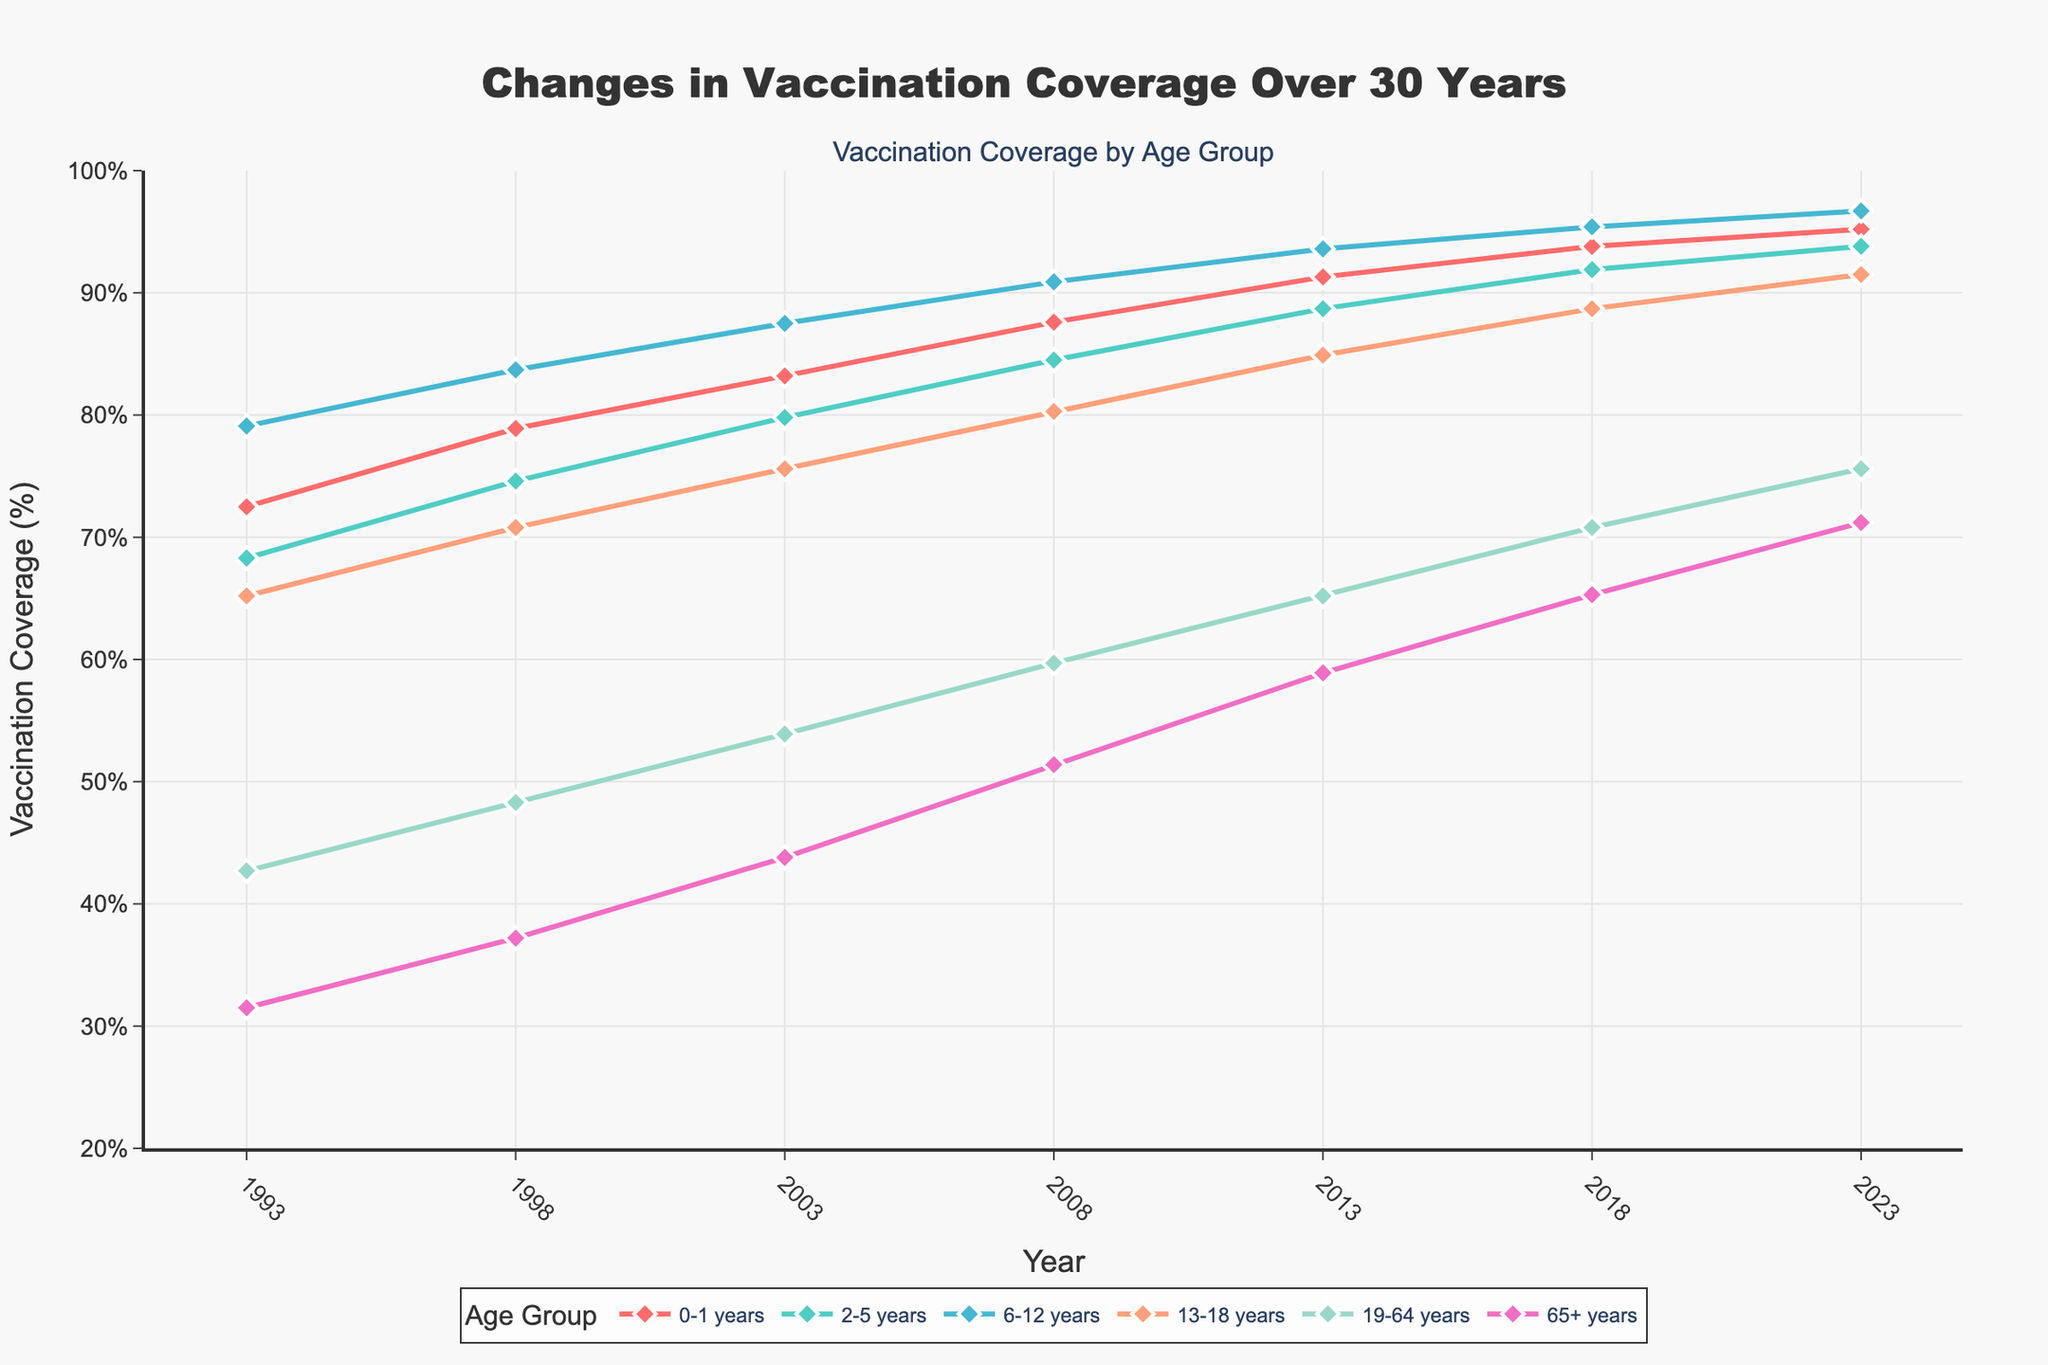What's the trend in vaccination coverage for the 0-1 years age group over the 30-year period? To understand the trend, observe the line representing the 0-1 years age group from 1993 to 2023. The line shows a continuous increase from 72.5% in 1993 to 95.2% in 2023, indicating a positive trend in vaccination coverage.
Answer: Increasing Which age group had the highest vaccination coverage in 2023? Review the endpoints of each line in 2023. The 6-12 years age group has the highest vaccination coverage at 96.7%.
Answer: 6-12 years By how many percentage points did the vaccination coverage for the 19-64 years age group increase from 1993 to 2023? Look at the values for the 19-64 years age group in 1993 and 2023. The coverage increased from 42.7% in 1993 to 75.6% in 2023. The difference is 75.6% - 42.7% = 32.9 percentage points.
Answer: 32.9 percentage points Compare the vaccination coverage between the 2-5 years and 13-18 years age groups in 2008. Which had higher coverage and by how much? In 2008, the coverage for the 2-5 years age group was 84.5% and for the 13-18 years age group was 80.3%. The difference is 84.5% - 80.3% = 4.2%, with the 2-5 years group having higher coverage.
Answer: 2-5 years by 4.2% What is the average vaccination coverage for the 65+ years age group across all the years shown? Add the coverage percentages for the 65+ years age group in all the years (31.5, 37.2, 43.8, 51.4, 58.9, 65.3, 71.2) and divide by the number of years (7). (31.5 + 37.2 + 43.8 + 51.4 + 58.9 + 65.3 + 71.2) / 7 = 51.84%.
Answer: 51.84% Which age group has the most significant increase in vaccination coverage from 1993 to 2023? Calculate the difference in coverage for all age groups between 1993 and 2023. The 0-1 years group increased by 95.2 - 72.5 = 22.7%, the 2-5 years by 93.8 - 68.3 = 25.5%, the 6-12 years by 96.7 - 79.1 = 17.6%, the 13-18 years by 91.5 - 65.2 = 26.3%, the 19-64 years by 75.6 - 42.7 = 32.9%, and the 65+ years by 71.2 - 31.5 = 39.7%. The 65+ years age group has the most significant increase.
Answer: 65+ years Describe the vaccination coverage trend for the 13-18 years age group. The 13-18 years age group coverage increased consistently from 65.2% in 1993 to 91.5% in 2023, showing a positive trend with gradual increments.
Answer: Positive trend Between which consecutive years did the 2-5 years age group see the highest increase in vaccination coverage? Calculate the differences between consecutive years for the 2-5 years group: 1993-1998 (74.6 - 68.3 = 6.3%), 1998-2003 (79.8 - 74.6 = 5.2%), 2003-2008 (84.5 - 79.8 = 4.7%), 2008-2013 (88.7 - 84.5 = 4.2%), 2013-2018 (91.9 - 88.7 = 3.2%), and 2018-2023 (93.8 - 91.9 = 1.9%). The highest increase was from 1993 to 1998 with 6.3%.
Answer: 1993-1998 What has been the overall percentage change in vaccination coverage for the 65+ years age group over the 30 years? Calculate the percentage change using the formula: ((new value - old value) / old value) * 100. For the 65+ years group: ((71.2 - 31.5) / 31.5) * 100 = 126.35%.
Answer: 126.35% 